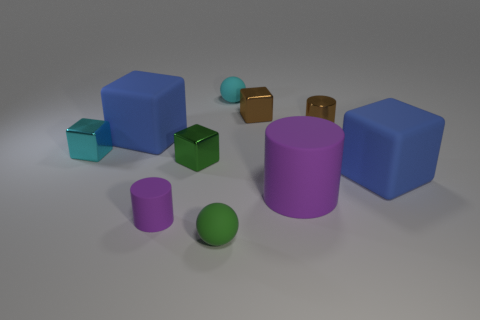Subtract all rubber cylinders. How many cylinders are left? 1 Subtract all brown cylinders. How many cylinders are left? 2 Add 5 small purple cylinders. How many small purple cylinders exist? 6 Subtract 0 brown spheres. How many objects are left? 10 Subtract all spheres. How many objects are left? 8 Subtract 1 spheres. How many spheres are left? 1 Subtract all brown blocks. Subtract all purple spheres. How many blocks are left? 4 Subtract all gray cylinders. How many cyan cubes are left? 1 Subtract all cubes. Subtract all small yellow spheres. How many objects are left? 5 Add 1 big things. How many big things are left? 4 